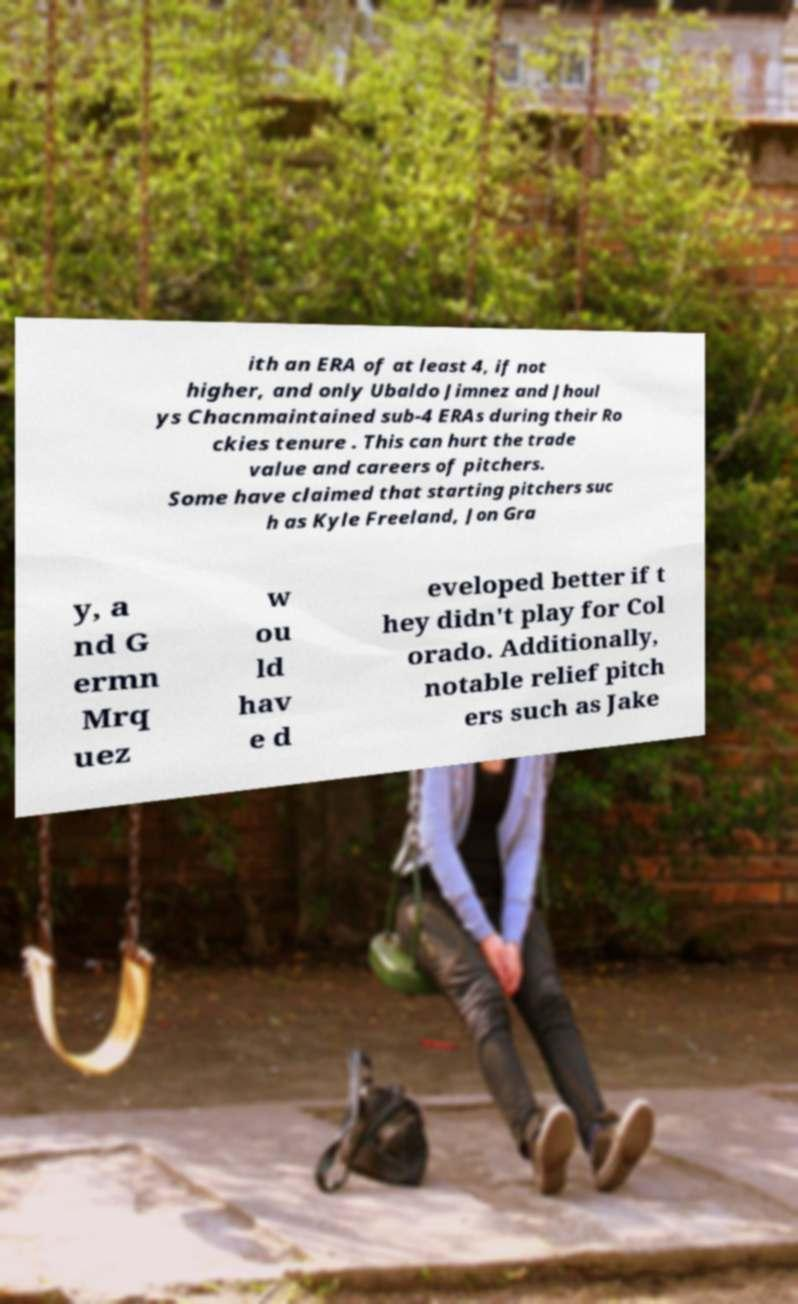Could you assist in decoding the text presented in this image and type it out clearly? ith an ERA of at least 4, if not higher, and only Ubaldo Jimnez and Jhoul ys Chacnmaintained sub-4 ERAs during their Ro ckies tenure . This can hurt the trade value and careers of pitchers. Some have claimed that starting pitchers suc h as Kyle Freeland, Jon Gra y, a nd G ermn Mrq uez w ou ld hav e d eveloped better if t hey didn't play for Col orado. Additionally, notable relief pitch ers such as Jake 